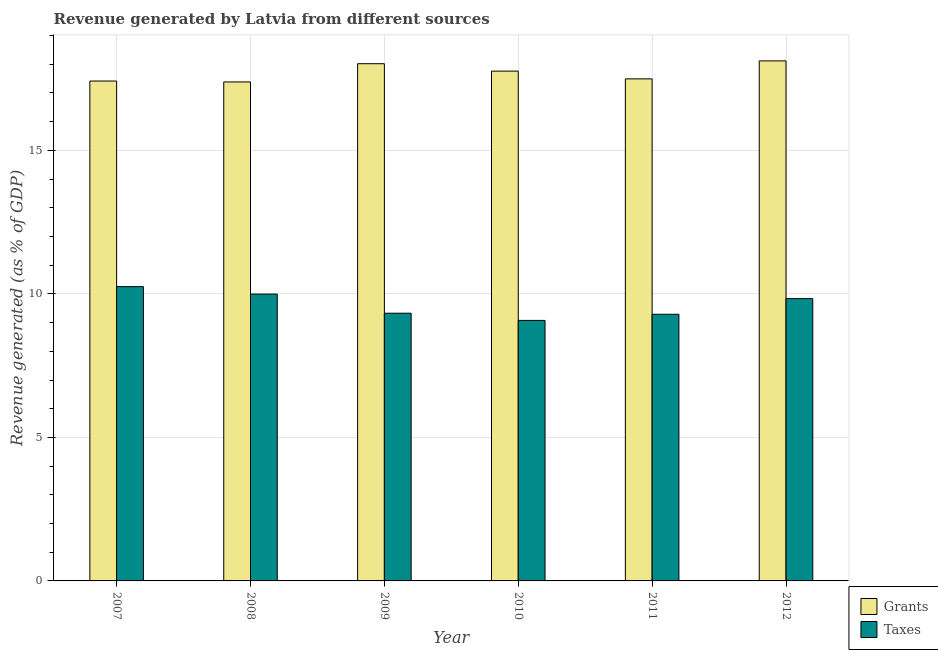Are the number of bars per tick equal to the number of legend labels?
Keep it short and to the point. Yes. In how many cases, is the number of bars for a given year not equal to the number of legend labels?
Keep it short and to the point. 0. What is the revenue generated by grants in 2011?
Make the answer very short. 17.49. Across all years, what is the maximum revenue generated by taxes?
Provide a succinct answer. 10.25. Across all years, what is the minimum revenue generated by grants?
Your response must be concise. 17.38. In which year was the revenue generated by grants minimum?
Make the answer very short. 2008. What is the total revenue generated by taxes in the graph?
Your answer should be compact. 57.78. What is the difference between the revenue generated by grants in 2008 and that in 2009?
Keep it short and to the point. -0.64. What is the difference between the revenue generated by grants in 2011 and the revenue generated by taxes in 2008?
Your answer should be compact. 0.11. What is the average revenue generated by taxes per year?
Make the answer very short. 9.63. In the year 2009, what is the difference between the revenue generated by taxes and revenue generated by grants?
Ensure brevity in your answer.  0. What is the ratio of the revenue generated by taxes in 2007 to that in 2010?
Give a very brief answer. 1.13. Is the difference between the revenue generated by taxes in 2008 and 2009 greater than the difference between the revenue generated by grants in 2008 and 2009?
Offer a very short reply. No. What is the difference between the highest and the second highest revenue generated by taxes?
Ensure brevity in your answer.  0.26. What is the difference between the highest and the lowest revenue generated by grants?
Offer a very short reply. 0.73. In how many years, is the revenue generated by grants greater than the average revenue generated by grants taken over all years?
Ensure brevity in your answer.  3. What does the 2nd bar from the left in 2007 represents?
Ensure brevity in your answer.  Taxes. What does the 2nd bar from the right in 2010 represents?
Provide a short and direct response. Grants. Are all the bars in the graph horizontal?
Your answer should be very brief. No. How many years are there in the graph?
Offer a very short reply. 6. What is the difference between two consecutive major ticks on the Y-axis?
Offer a very short reply. 5. Does the graph contain any zero values?
Offer a very short reply. No. Where does the legend appear in the graph?
Provide a short and direct response. Bottom right. What is the title of the graph?
Provide a short and direct response. Revenue generated by Latvia from different sources. What is the label or title of the Y-axis?
Make the answer very short. Revenue generated (as % of GDP). What is the Revenue generated (as % of GDP) of Grants in 2007?
Offer a very short reply. 17.42. What is the Revenue generated (as % of GDP) in Taxes in 2007?
Your answer should be very brief. 10.25. What is the Revenue generated (as % of GDP) in Grants in 2008?
Ensure brevity in your answer.  17.38. What is the Revenue generated (as % of GDP) in Taxes in 2008?
Provide a short and direct response. 9.99. What is the Revenue generated (as % of GDP) in Grants in 2009?
Your answer should be very brief. 18.02. What is the Revenue generated (as % of GDP) in Taxes in 2009?
Offer a terse response. 9.33. What is the Revenue generated (as % of GDP) in Grants in 2010?
Give a very brief answer. 17.76. What is the Revenue generated (as % of GDP) of Taxes in 2010?
Offer a terse response. 9.08. What is the Revenue generated (as % of GDP) in Grants in 2011?
Offer a very short reply. 17.49. What is the Revenue generated (as % of GDP) of Taxes in 2011?
Keep it short and to the point. 9.29. What is the Revenue generated (as % of GDP) of Grants in 2012?
Your response must be concise. 18.12. What is the Revenue generated (as % of GDP) of Taxes in 2012?
Give a very brief answer. 9.84. Across all years, what is the maximum Revenue generated (as % of GDP) in Grants?
Your response must be concise. 18.12. Across all years, what is the maximum Revenue generated (as % of GDP) of Taxes?
Give a very brief answer. 10.25. Across all years, what is the minimum Revenue generated (as % of GDP) of Grants?
Your response must be concise. 17.38. Across all years, what is the minimum Revenue generated (as % of GDP) of Taxes?
Keep it short and to the point. 9.08. What is the total Revenue generated (as % of GDP) of Grants in the graph?
Give a very brief answer. 106.19. What is the total Revenue generated (as % of GDP) of Taxes in the graph?
Offer a very short reply. 57.78. What is the difference between the Revenue generated (as % of GDP) in Grants in 2007 and that in 2008?
Provide a short and direct response. 0.03. What is the difference between the Revenue generated (as % of GDP) of Taxes in 2007 and that in 2008?
Your answer should be very brief. 0.26. What is the difference between the Revenue generated (as % of GDP) of Grants in 2007 and that in 2009?
Provide a short and direct response. -0.6. What is the difference between the Revenue generated (as % of GDP) of Taxes in 2007 and that in 2009?
Offer a very short reply. 0.93. What is the difference between the Revenue generated (as % of GDP) of Grants in 2007 and that in 2010?
Ensure brevity in your answer.  -0.35. What is the difference between the Revenue generated (as % of GDP) in Taxes in 2007 and that in 2010?
Keep it short and to the point. 1.18. What is the difference between the Revenue generated (as % of GDP) of Grants in 2007 and that in 2011?
Your answer should be very brief. -0.08. What is the difference between the Revenue generated (as % of GDP) in Taxes in 2007 and that in 2011?
Offer a terse response. 0.96. What is the difference between the Revenue generated (as % of GDP) of Grants in 2007 and that in 2012?
Offer a terse response. -0.7. What is the difference between the Revenue generated (as % of GDP) of Taxes in 2007 and that in 2012?
Offer a very short reply. 0.42. What is the difference between the Revenue generated (as % of GDP) in Grants in 2008 and that in 2009?
Provide a succinct answer. -0.64. What is the difference between the Revenue generated (as % of GDP) in Taxes in 2008 and that in 2009?
Offer a very short reply. 0.67. What is the difference between the Revenue generated (as % of GDP) of Grants in 2008 and that in 2010?
Make the answer very short. -0.38. What is the difference between the Revenue generated (as % of GDP) of Taxes in 2008 and that in 2010?
Your answer should be very brief. 0.92. What is the difference between the Revenue generated (as % of GDP) in Grants in 2008 and that in 2011?
Provide a succinct answer. -0.11. What is the difference between the Revenue generated (as % of GDP) of Taxes in 2008 and that in 2011?
Your answer should be compact. 0.7. What is the difference between the Revenue generated (as % of GDP) of Grants in 2008 and that in 2012?
Your answer should be very brief. -0.73. What is the difference between the Revenue generated (as % of GDP) of Taxes in 2008 and that in 2012?
Your answer should be compact. 0.16. What is the difference between the Revenue generated (as % of GDP) in Grants in 2009 and that in 2010?
Make the answer very short. 0.26. What is the difference between the Revenue generated (as % of GDP) in Taxes in 2009 and that in 2010?
Your answer should be very brief. 0.25. What is the difference between the Revenue generated (as % of GDP) in Grants in 2009 and that in 2011?
Give a very brief answer. 0.53. What is the difference between the Revenue generated (as % of GDP) in Taxes in 2009 and that in 2011?
Your answer should be compact. 0.04. What is the difference between the Revenue generated (as % of GDP) in Grants in 2009 and that in 2012?
Your answer should be compact. -0.1. What is the difference between the Revenue generated (as % of GDP) of Taxes in 2009 and that in 2012?
Ensure brevity in your answer.  -0.51. What is the difference between the Revenue generated (as % of GDP) of Grants in 2010 and that in 2011?
Provide a short and direct response. 0.27. What is the difference between the Revenue generated (as % of GDP) in Taxes in 2010 and that in 2011?
Provide a succinct answer. -0.21. What is the difference between the Revenue generated (as % of GDP) of Grants in 2010 and that in 2012?
Keep it short and to the point. -0.36. What is the difference between the Revenue generated (as % of GDP) in Taxes in 2010 and that in 2012?
Make the answer very short. -0.76. What is the difference between the Revenue generated (as % of GDP) of Grants in 2011 and that in 2012?
Ensure brevity in your answer.  -0.63. What is the difference between the Revenue generated (as % of GDP) of Taxes in 2011 and that in 2012?
Offer a terse response. -0.54. What is the difference between the Revenue generated (as % of GDP) in Grants in 2007 and the Revenue generated (as % of GDP) in Taxes in 2008?
Ensure brevity in your answer.  7.42. What is the difference between the Revenue generated (as % of GDP) in Grants in 2007 and the Revenue generated (as % of GDP) in Taxes in 2009?
Offer a very short reply. 8.09. What is the difference between the Revenue generated (as % of GDP) in Grants in 2007 and the Revenue generated (as % of GDP) in Taxes in 2010?
Provide a short and direct response. 8.34. What is the difference between the Revenue generated (as % of GDP) in Grants in 2007 and the Revenue generated (as % of GDP) in Taxes in 2011?
Make the answer very short. 8.13. What is the difference between the Revenue generated (as % of GDP) in Grants in 2007 and the Revenue generated (as % of GDP) in Taxes in 2012?
Offer a very short reply. 7.58. What is the difference between the Revenue generated (as % of GDP) in Grants in 2008 and the Revenue generated (as % of GDP) in Taxes in 2009?
Give a very brief answer. 8.06. What is the difference between the Revenue generated (as % of GDP) in Grants in 2008 and the Revenue generated (as % of GDP) in Taxes in 2010?
Keep it short and to the point. 8.31. What is the difference between the Revenue generated (as % of GDP) of Grants in 2008 and the Revenue generated (as % of GDP) of Taxes in 2011?
Your answer should be very brief. 8.09. What is the difference between the Revenue generated (as % of GDP) in Grants in 2008 and the Revenue generated (as % of GDP) in Taxes in 2012?
Ensure brevity in your answer.  7.55. What is the difference between the Revenue generated (as % of GDP) in Grants in 2009 and the Revenue generated (as % of GDP) in Taxes in 2010?
Your answer should be very brief. 8.94. What is the difference between the Revenue generated (as % of GDP) in Grants in 2009 and the Revenue generated (as % of GDP) in Taxes in 2011?
Offer a terse response. 8.73. What is the difference between the Revenue generated (as % of GDP) in Grants in 2009 and the Revenue generated (as % of GDP) in Taxes in 2012?
Keep it short and to the point. 8.18. What is the difference between the Revenue generated (as % of GDP) in Grants in 2010 and the Revenue generated (as % of GDP) in Taxes in 2011?
Your answer should be compact. 8.47. What is the difference between the Revenue generated (as % of GDP) of Grants in 2010 and the Revenue generated (as % of GDP) of Taxes in 2012?
Provide a short and direct response. 7.93. What is the difference between the Revenue generated (as % of GDP) of Grants in 2011 and the Revenue generated (as % of GDP) of Taxes in 2012?
Keep it short and to the point. 7.66. What is the average Revenue generated (as % of GDP) in Grants per year?
Make the answer very short. 17.7. What is the average Revenue generated (as % of GDP) in Taxes per year?
Provide a short and direct response. 9.63. In the year 2007, what is the difference between the Revenue generated (as % of GDP) in Grants and Revenue generated (as % of GDP) in Taxes?
Provide a short and direct response. 7.16. In the year 2008, what is the difference between the Revenue generated (as % of GDP) of Grants and Revenue generated (as % of GDP) of Taxes?
Give a very brief answer. 7.39. In the year 2009, what is the difference between the Revenue generated (as % of GDP) in Grants and Revenue generated (as % of GDP) in Taxes?
Your answer should be compact. 8.69. In the year 2010, what is the difference between the Revenue generated (as % of GDP) of Grants and Revenue generated (as % of GDP) of Taxes?
Your response must be concise. 8.69. In the year 2011, what is the difference between the Revenue generated (as % of GDP) of Grants and Revenue generated (as % of GDP) of Taxes?
Provide a short and direct response. 8.2. In the year 2012, what is the difference between the Revenue generated (as % of GDP) in Grants and Revenue generated (as % of GDP) in Taxes?
Offer a terse response. 8.28. What is the ratio of the Revenue generated (as % of GDP) of Grants in 2007 to that in 2008?
Keep it short and to the point. 1. What is the ratio of the Revenue generated (as % of GDP) in Taxes in 2007 to that in 2008?
Your answer should be very brief. 1.03. What is the ratio of the Revenue generated (as % of GDP) in Grants in 2007 to that in 2009?
Keep it short and to the point. 0.97. What is the ratio of the Revenue generated (as % of GDP) in Taxes in 2007 to that in 2009?
Your answer should be compact. 1.1. What is the ratio of the Revenue generated (as % of GDP) of Grants in 2007 to that in 2010?
Provide a succinct answer. 0.98. What is the ratio of the Revenue generated (as % of GDP) in Taxes in 2007 to that in 2010?
Your answer should be very brief. 1.13. What is the ratio of the Revenue generated (as % of GDP) of Taxes in 2007 to that in 2011?
Your answer should be very brief. 1.1. What is the ratio of the Revenue generated (as % of GDP) in Grants in 2007 to that in 2012?
Keep it short and to the point. 0.96. What is the ratio of the Revenue generated (as % of GDP) in Taxes in 2007 to that in 2012?
Keep it short and to the point. 1.04. What is the ratio of the Revenue generated (as % of GDP) in Grants in 2008 to that in 2009?
Your answer should be compact. 0.96. What is the ratio of the Revenue generated (as % of GDP) of Taxes in 2008 to that in 2009?
Give a very brief answer. 1.07. What is the ratio of the Revenue generated (as % of GDP) in Grants in 2008 to that in 2010?
Your answer should be compact. 0.98. What is the ratio of the Revenue generated (as % of GDP) in Taxes in 2008 to that in 2010?
Provide a succinct answer. 1.1. What is the ratio of the Revenue generated (as % of GDP) in Taxes in 2008 to that in 2011?
Provide a short and direct response. 1.08. What is the ratio of the Revenue generated (as % of GDP) in Grants in 2008 to that in 2012?
Ensure brevity in your answer.  0.96. What is the ratio of the Revenue generated (as % of GDP) in Taxes in 2008 to that in 2012?
Your answer should be compact. 1.02. What is the ratio of the Revenue generated (as % of GDP) in Grants in 2009 to that in 2010?
Your response must be concise. 1.01. What is the ratio of the Revenue generated (as % of GDP) in Taxes in 2009 to that in 2010?
Your response must be concise. 1.03. What is the ratio of the Revenue generated (as % of GDP) of Grants in 2009 to that in 2011?
Offer a very short reply. 1.03. What is the ratio of the Revenue generated (as % of GDP) in Taxes in 2009 to that in 2011?
Your response must be concise. 1. What is the ratio of the Revenue generated (as % of GDP) in Taxes in 2009 to that in 2012?
Offer a very short reply. 0.95. What is the ratio of the Revenue generated (as % of GDP) in Grants in 2010 to that in 2011?
Provide a succinct answer. 1.02. What is the ratio of the Revenue generated (as % of GDP) of Taxes in 2010 to that in 2011?
Your answer should be compact. 0.98. What is the ratio of the Revenue generated (as % of GDP) of Grants in 2010 to that in 2012?
Your answer should be very brief. 0.98. What is the ratio of the Revenue generated (as % of GDP) in Taxes in 2010 to that in 2012?
Provide a succinct answer. 0.92. What is the ratio of the Revenue generated (as % of GDP) in Grants in 2011 to that in 2012?
Provide a short and direct response. 0.97. What is the ratio of the Revenue generated (as % of GDP) in Taxes in 2011 to that in 2012?
Provide a succinct answer. 0.94. What is the difference between the highest and the second highest Revenue generated (as % of GDP) in Grants?
Provide a short and direct response. 0.1. What is the difference between the highest and the second highest Revenue generated (as % of GDP) in Taxes?
Your response must be concise. 0.26. What is the difference between the highest and the lowest Revenue generated (as % of GDP) of Grants?
Offer a terse response. 0.73. What is the difference between the highest and the lowest Revenue generated (as % of GDP) in Taxes?
Your answer should be very brief. 1.18. 